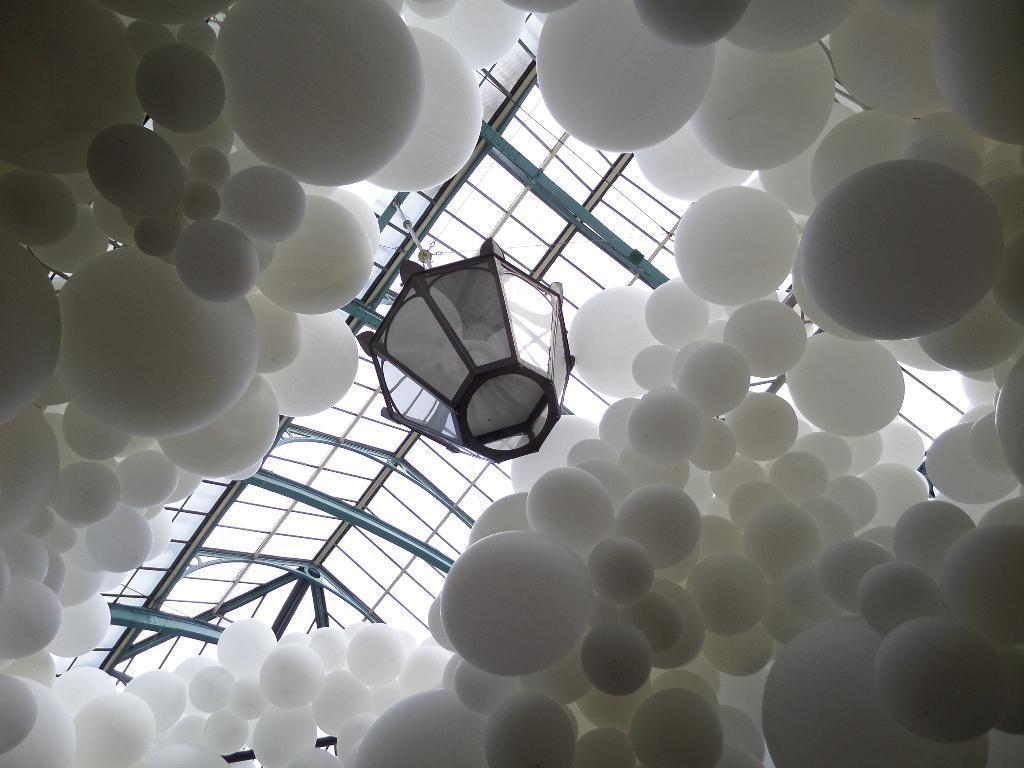In one or two sentences, can you explain what this image depicts? In this image there is a lamp which is tied to the rope. There are white color balloons around it. At the top there is roof. 